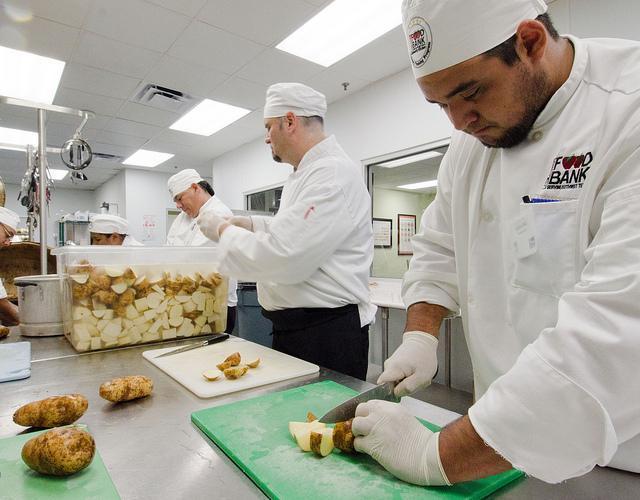How many people are in the photo?
Give a very brief answer. 3. How many teddy bears are in the scene?
Give a very brief answer. 0. 